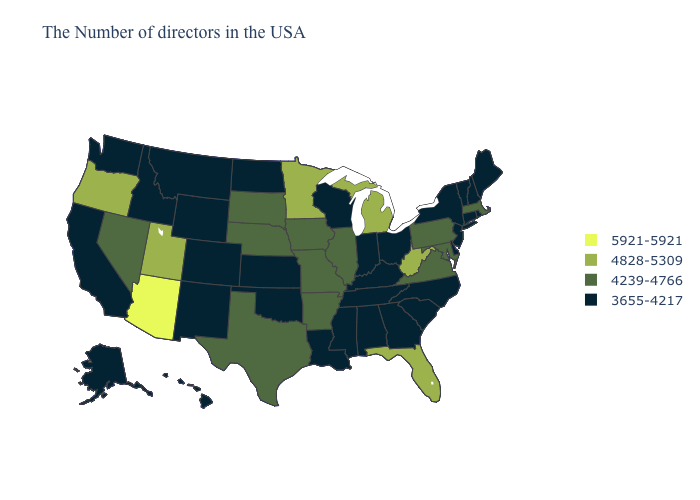What is the highest value in the USA?
Short answer required. 5921-5921. What is the highest value in the MidWest ?
Short answer required. 4828-5309. Which states have the highest value in the USA?
Answer briefly. Arizona. Does Minnesota have a higher value than Utah?
Short answer required. No. Name the states that have a value in the range 4828-5309?
Answer briefly. West Virginia, Florida, Michigan, Minnesota, Utah, Oregon. What is the value of New York?
Answer briefly. 3655-4217. Which states have the highest value in the USA?
Give a very brief answer. Arizona. What is the value of New York?
Give a very brief answer. 3655-4217. Does New Hampshire have a lower value than Arizona?
Write a very short answer. Yes. Name the states that have a value in the range 5921-5921?
Concise answer only. Arizona. Among the states that border Delaware , does New Jersey have the highest value?
Quick response, please. No. What is the lowest value in the Northeast?
Short answer required. 3655-4217. What is the value of Pennsylvania?
Concise answer only. 4239-4766. What is the lowest value in states that border Ohio?
Short answer required. 3655-4217. Does Alabama have the lowest value in the South?
Short answer required. Yes. 